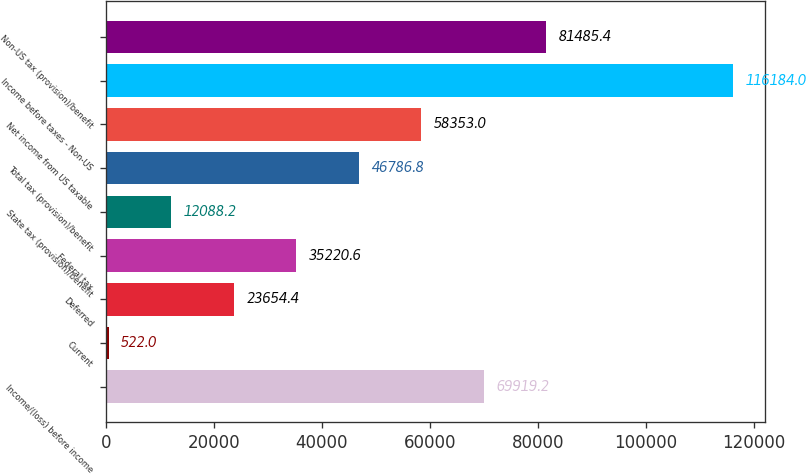Convert chart to OTSL. <chart><loc_0><loc_0><loc_500><loc_500><bar_chart><fcel>Income/(loss) before income<fcel>Current<fcel>Deferred<fcel>Federal tax<fcel>State tax (provision)/benefit<fcel>Total tax (provision)/benefit<fcel>Net income from US taxable<fcel>Income before taxes - Non-US<fcel>Non-US tax (provision)/benefit<nl><fcel>69919.2<fcel>522<fcel>23654.4<fcel>35220.6<fcel>12088.2<fcel>46786.8<fcel>58353<fcel>116184<fcel>81485.4<nl></chart> 